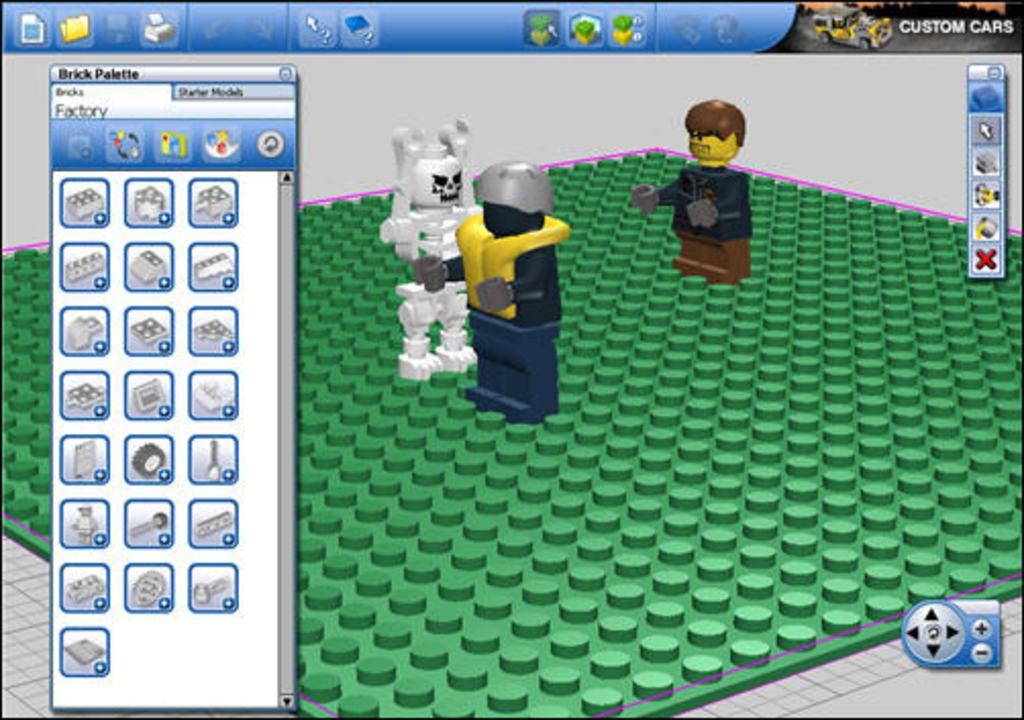Provide a one-sentence caption for the provided image. a video game screen with Custom Cars option on top right corner. 